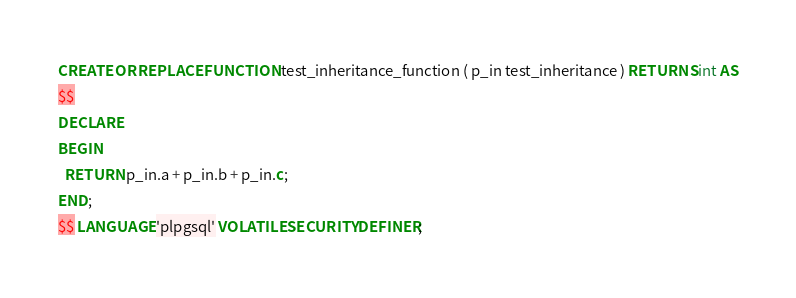Convert code to text. <code><loc_0><loc_0><loc_500><loc_500><_SQL_>CREATE OR REPLACE FUNCTION test_inheritance_function ( p_in test_inheritance ) RETURNS int AS
$$
DECLARE
BEGIN
  RETURN p_in.a + p_in.b + p_in.c;
END;
$$ LANGUAGE 'plpgsql' VOLATILE SECURITY DEFINER;
</code> 